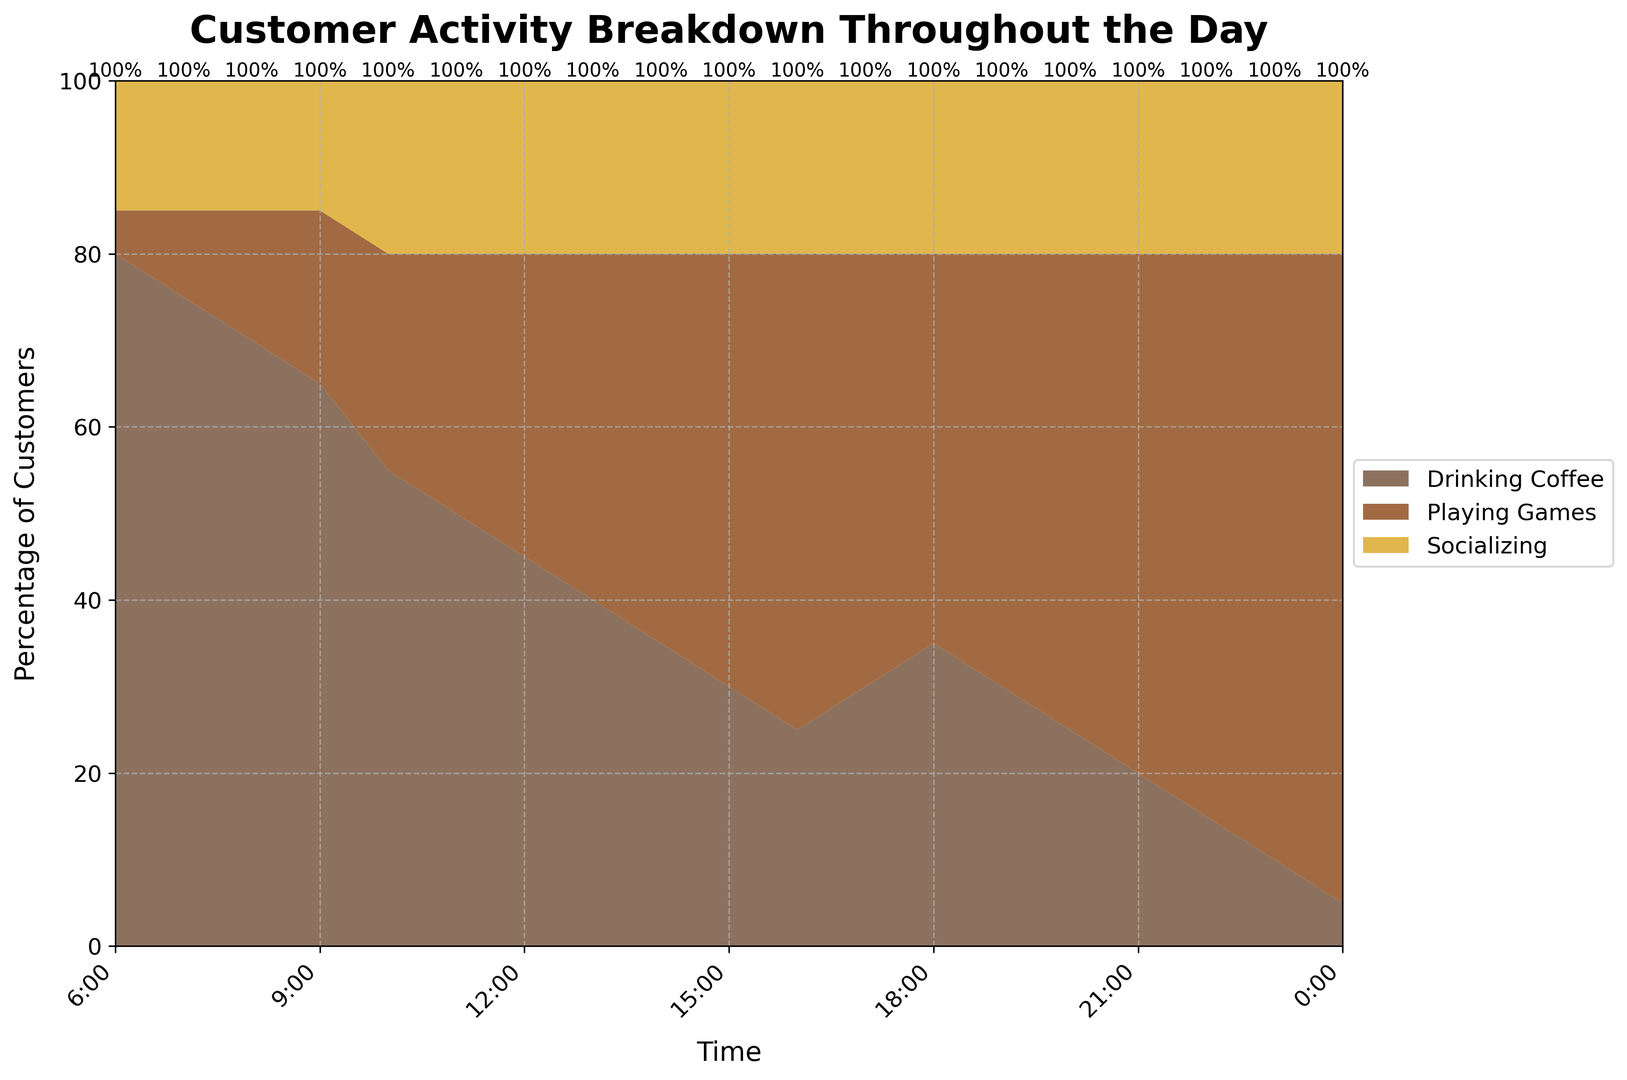What is the highest percentage of customers playing games at any given time? To find the highest percentage of customers playing games, look for the peak of the "Playing Games" segment in the stacked area chart. This peak occurs at 0:00.
Answer: 75% At what time does socializing have the smallest percentage of customers? Check the "Socializing" segment across the time axis to identify the smallest percentage. It remains constant at 15% from 6:00 to 9:00.
Answer: 6:00 to 9:00 When do customers spend more time drinking coffee compared to playing games and socializing combined? Compare the "Drinking Coffee" area with the sum of "Playing Games" and "Socializing" areas. Through 6:00 to 8:00, coffee consumption consistently surpasses the combination of the other activities.
Answer: 6:00 to 8:00 How does the percentage of customers playing games change between 10:00 and 16:00? Observe the "Playing Games" segment between these hours. It starts at 25% at 10:00 and increases steadily to 55% at 16:00.
Answer: Increases from 25% to 55% During which hours is the percentage of customers socializing constant? The "Socializing" segment's height stays same throughout the 24-hour period.
Answer: All day (constant at 20%) When is the time spent drinking coffee at its lowest? Look at the "Drinking Coffee" area to identify the lowest point, which occurs at 0:00.
Answer: 0:00 Compare the customer activity between 18:00 and 20:00. What trend is observed? From 18:00 to 20:00, the "Playing Games" percentage increases while "Drinking Coffee" decreases, and "Socializing" remains constant.
Answer: Increasing games, decreasing coffee, constant socializing What is the difference in the percentage of customers drinking coffee at 6:00 and 15:00? Subtract the percentage of customers drinking coffee at 15:00 (30%) from that at 6:00 (80%).
Answer: 50% Between 21:00 and 23:00, which activity shows the largest increase? Compare the "Playing Games" segment between these times, increasing from 60% at 21:00 to 70% at 23:00.
Answer: Playing games 